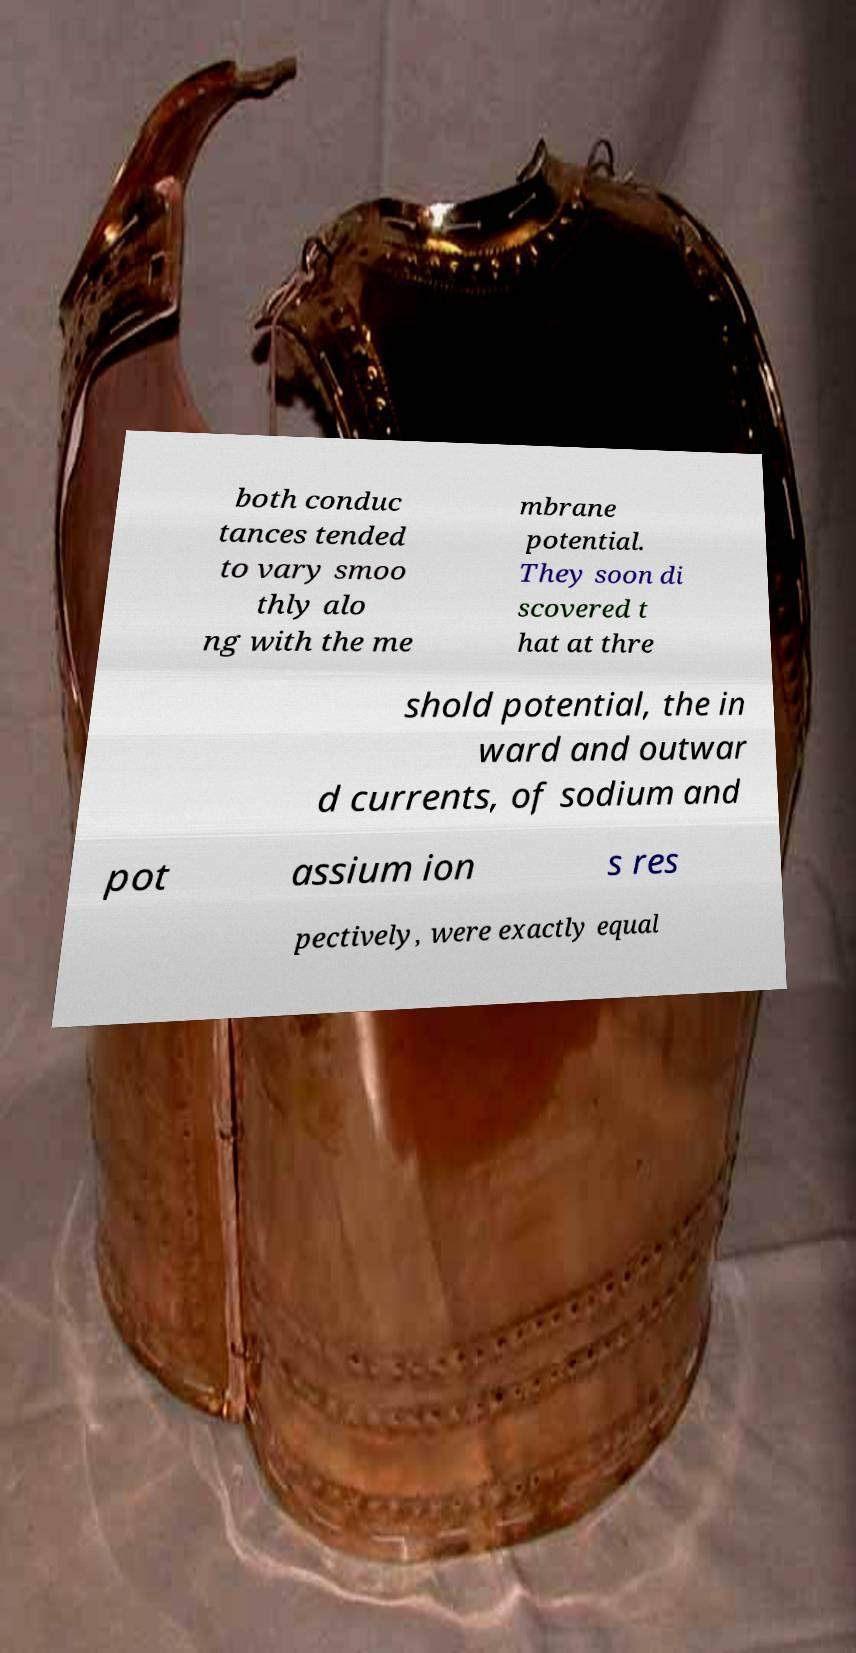Could you extract and type out the text from this image? both conduc tances tended to vary smoo thly alo ng with the me mbrane potential. They soon di scovered t hat at thre shold potential, the in ward and outwar d currents, of sodium and pot assium ion s res pectively, were exactly equal 